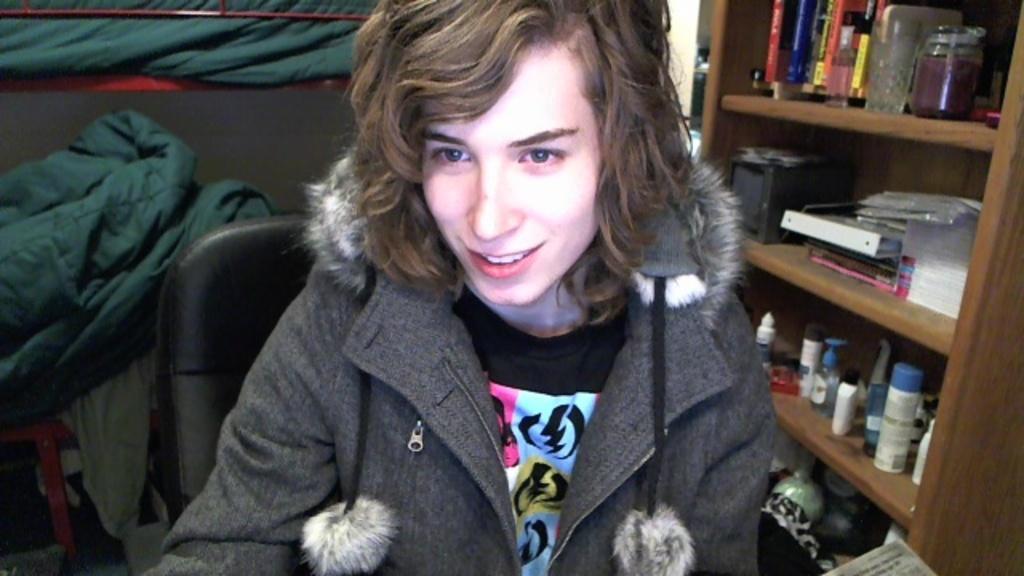How would you summarize this image in a sentence or two? In this image, we can see a human is sitting and smiling. Background we can see some clothes, board. Right side of the image, there is a wooden shelf. So many things and objects are placed on it. 